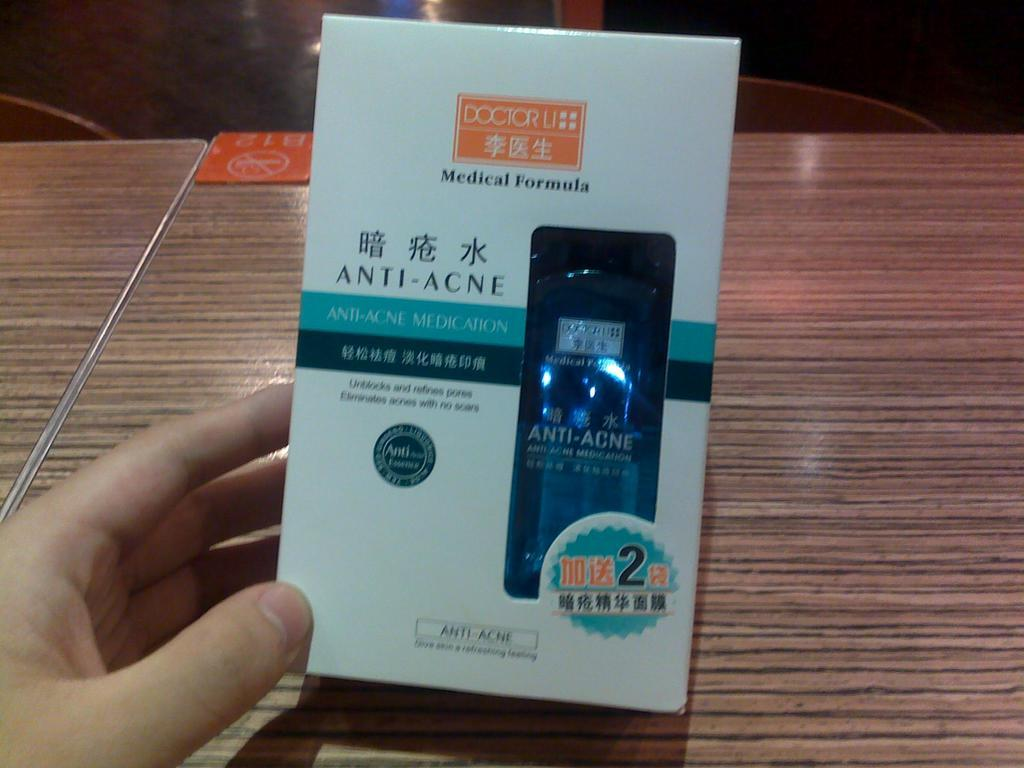<image>
Summarize the visual content of the image. A hand is holding a box of anti-acne medicine. 